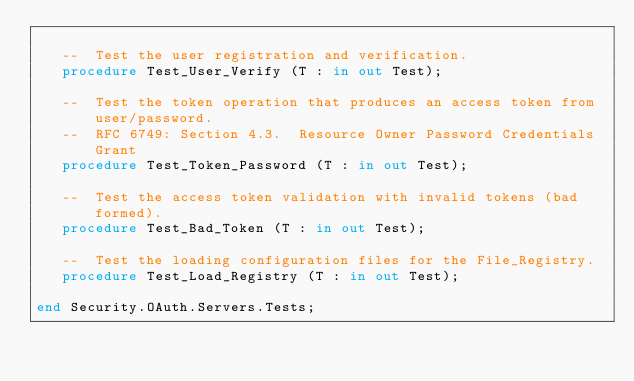Convert code to text. <code><loc_0><loc_0><loc_500><loc_500><_Ada_>
   --  Test the user registration and verification.
   procedure Test_User_Verify (T : in out Test);

   --  Test the token operation that produces an access token from user/password.
   --  RFC 6749: Section 4.3.  Resource Owner Password Credentials Grant
   procedure Test_Token_Password (T : in out Test);

   --  Test the access token validation with invalid tokens (bad formed).
   procedure Test_Bad_Token (T : in out Test);

   --  Test the loading configuration files for the File_Registry.
   procedure Test_Load_Registry (T : in out Test);

end Security.OAuth.Servers.Tests;
</code> 